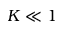Convert formula to latex. <formula><loc_0><loc_0><loc_500><loc_500>K \ll 1</formula> 